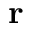<formula> <loc_0><loc_0><loc_500><loc_500>r</formula> 